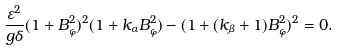Convert formula to latex. <formula><loc_0><loc_0><loc_500><loc_500>\frac { \varepsilon ^ { 2 } } { g \delta } ( 1 + B _ { \varphi } ^ { 2 } ) ^ { 2 } ( 1 + k _ { \alpha } B _ { \varphi } ^ { 2 } ) - ( 1 + ( k _ { \beta } + 1 ) B _ { \varphi } ^ { 2 } ) ^ { 2 } = 0 .</formula> 